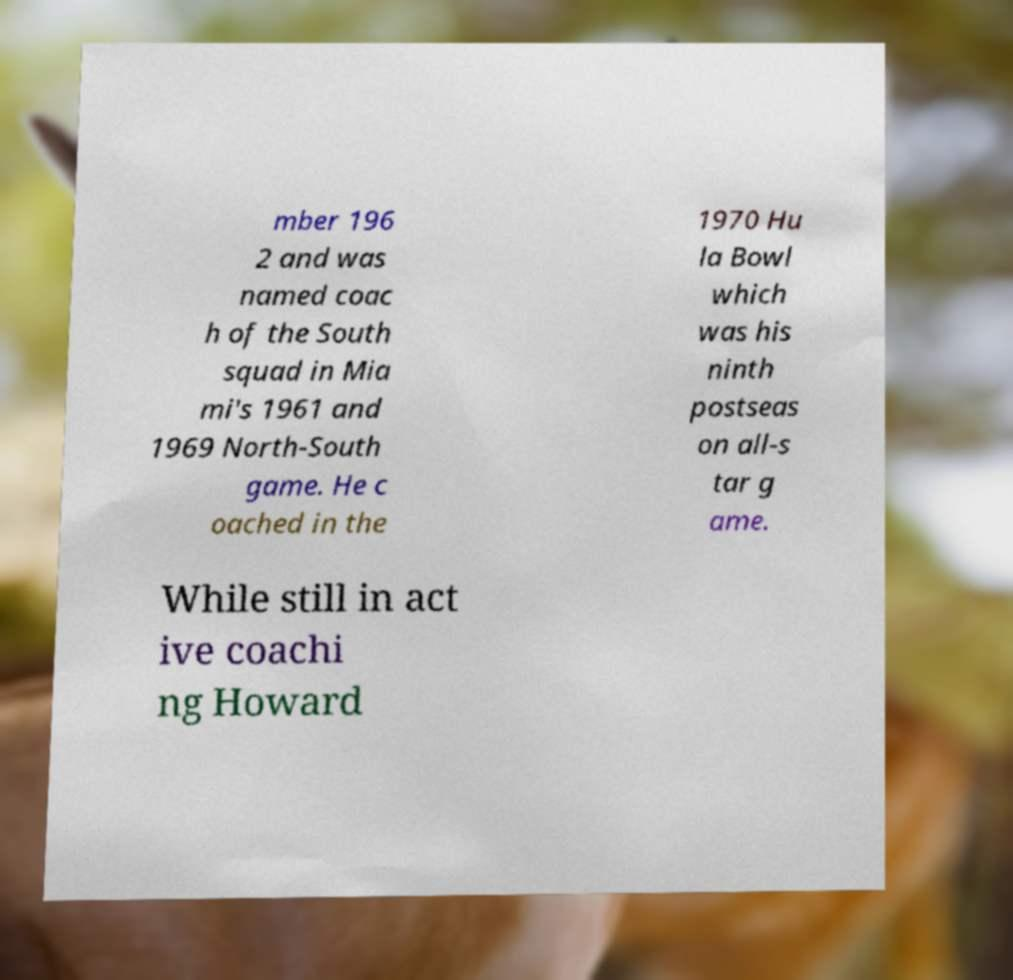Please identify and transcribe the text found in this image. mber 196 2 and was named coac h of the South squad in Mia mi's 1961 and 1969 North-South game. He c oached in the 1970 Hu la Bowl which was his ninth postseas on all-s tar g ame. While still in act ive coachi ng Howard 